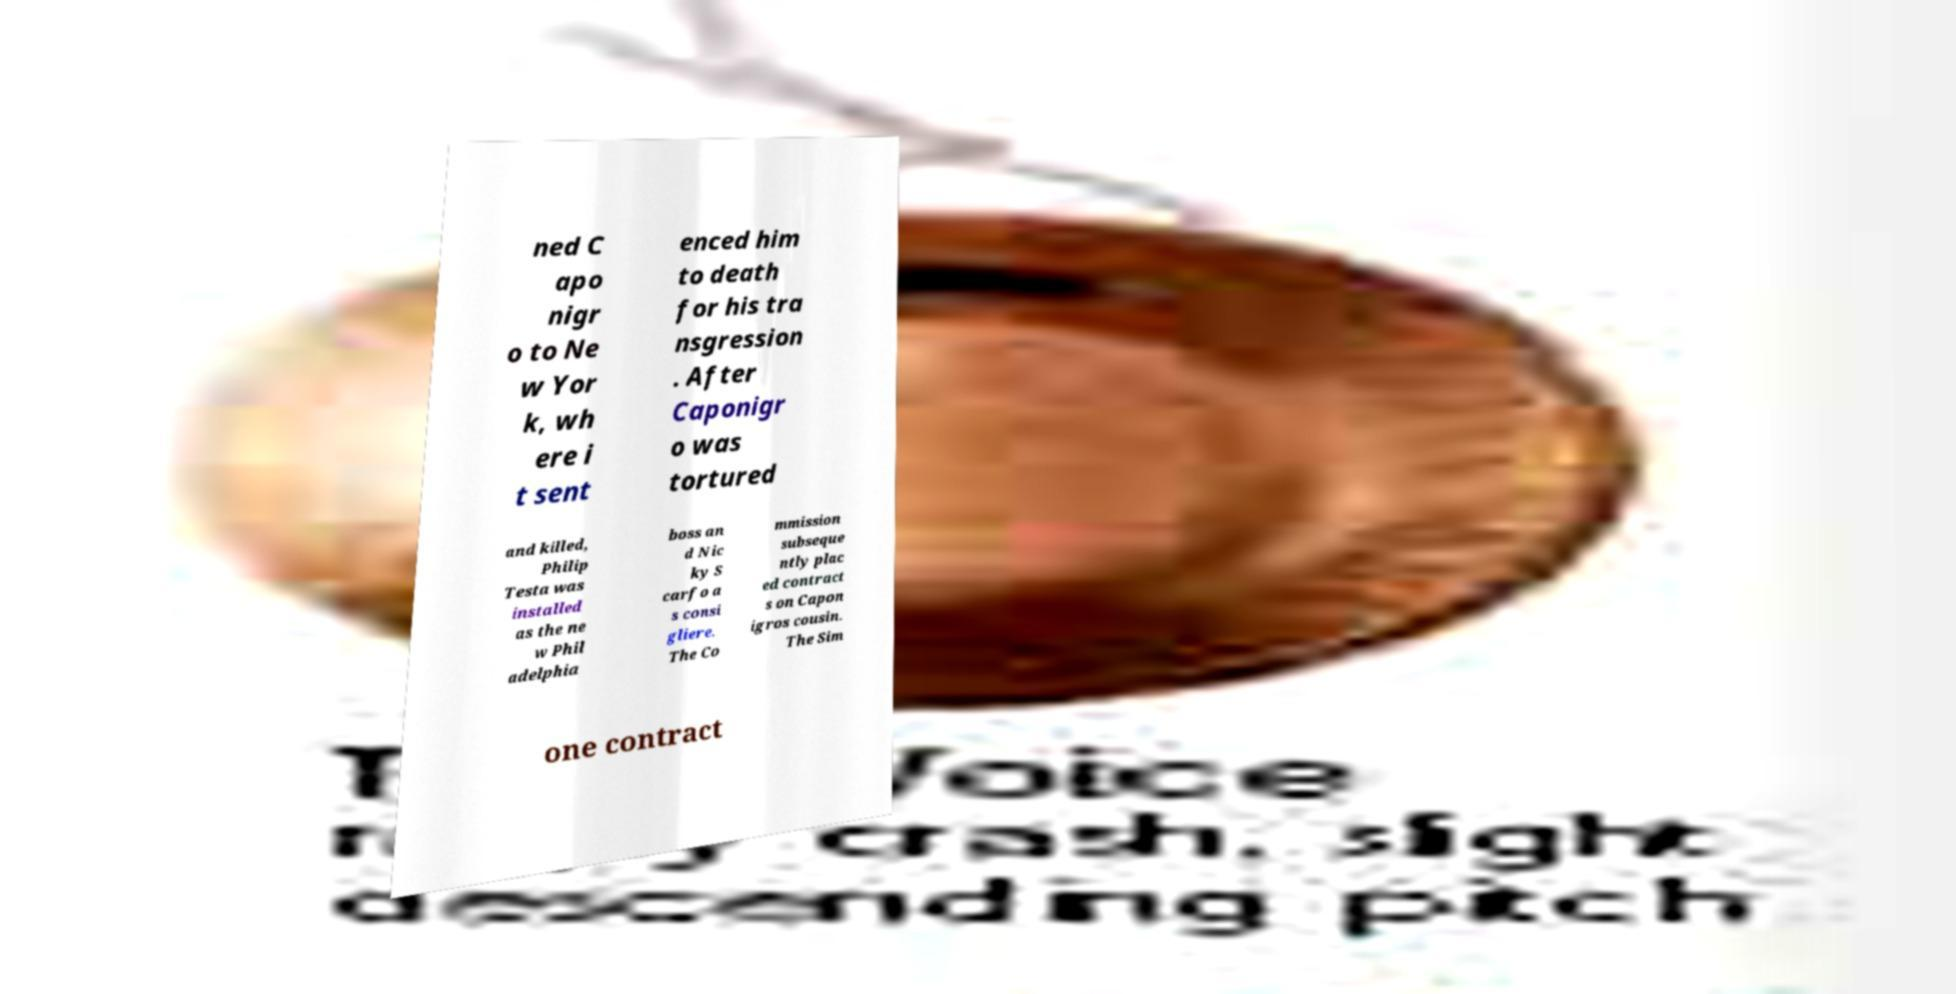I need the written content from this picture converted into text. Can you do that? ned C apo nigr o to Ne w Yor k, wh ere i t sent enced him to death for his tra nsgression . After Caponigr o was tortured and killed, Philip Testa was installed as the ne w Phil adelphia boss an d Nic ky S carfo a s consi gliere. The Co mmission subseque ntly plac ed contract s on Capon igros cousin. The Sim one contract 